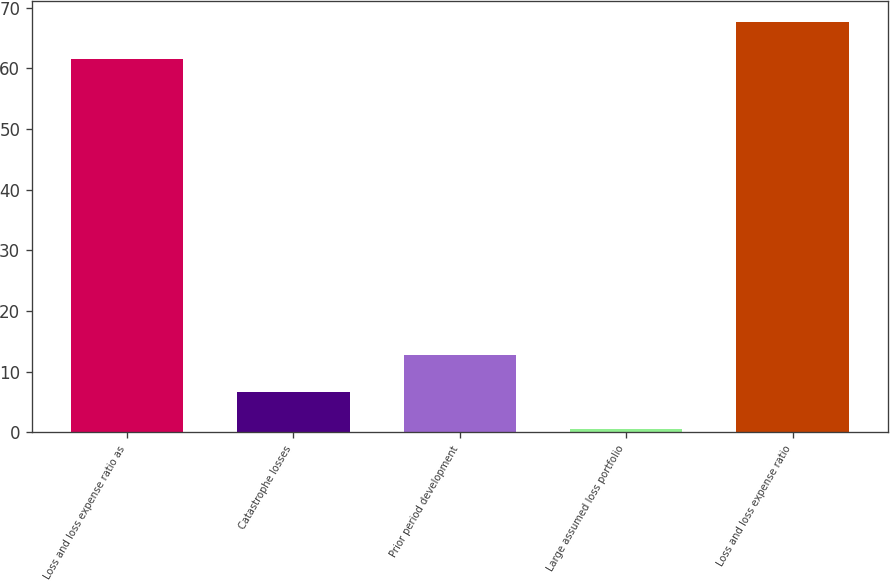Convert chart to OTSL. <chart><loc_0><loc_0><loc_500><loc_500><bar_chart><fcel>Loss and loss expense ratio as<fcel>Catastrophe losses<fcel>Prior period development<fcel>Large assumed loss portfolio<fcel>Loss and loss expense ratio<nl><fcel>61.6<fcel>6.61<fcel>12.72<fcel>0.5<fcel>67.71<nl></chart> 